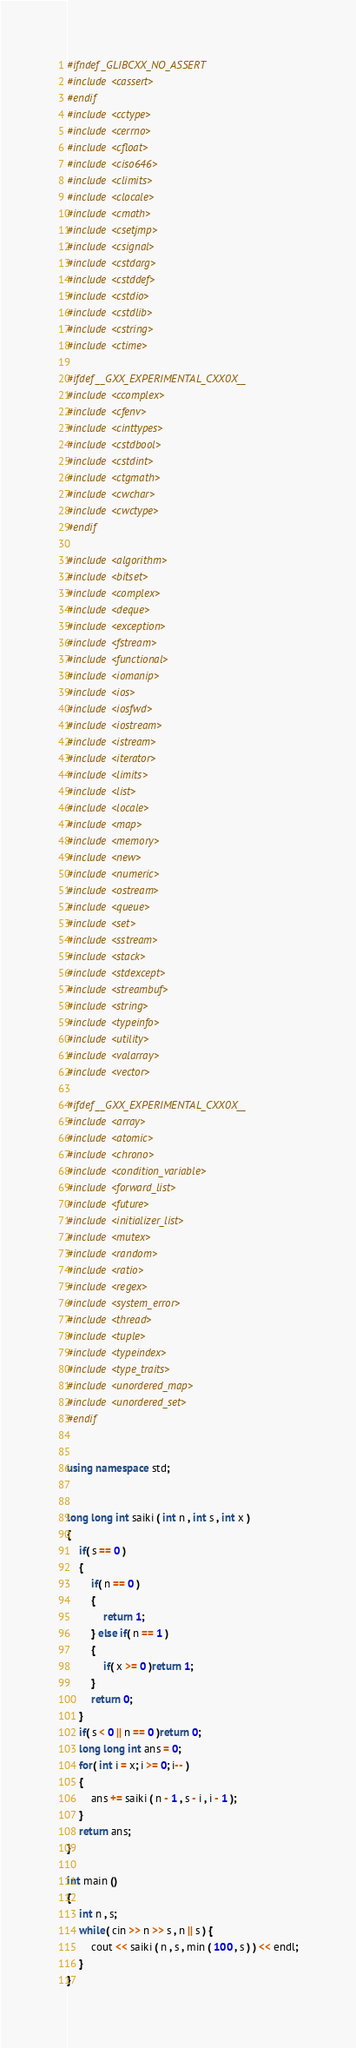Convert code to text. <code><loc_0><loc_0><loc_500><loc_500><_C++_>#ifndef _GLIBCXX_NO_ASSERT
#include <cassert>
#endif
#include <cctype>
#include <cerrno>
#include <cfloat>
#include <ciso646>
#include <climits>
#include <clocale>
#include <cmath>
#include <csetjmp>
#include <csignal>
#include <cstdarg>
#include <cstddef>
#include <cstdio>
#include <cstdlib>
#include <cstring>
#include <ctime>

#ifdef __GXX_EXPERIMENTAL_CXX0X__
#include <ccomplex>
#include <cfenv>
#include <cinttypes>
#include <cstdbool>
#include <cstdint>
#include <ctgmath>
#include <cwchar>
#include <cwctype>
#endif

#include <algorithm>
#include <bitset>
#include <complex>
#include <deque>
#include <exception>
#include <fstream>
#include <functional>
#include <iomanip>
#include <ios>
#include <iosfwd>
#include <iostream>
#include <istream>
#include <iterator>
#include <limits>
#include <list>
#include <locale>
#include <map>
#include <memory>
#include <new>
#include <numeric>
#include <ostream>
#include <queue>
#include <set>
#include <sstream>
#include <stack>
#include <stdexcept>
#include <streambuf>
#include <string>
#include <typeinfo>
#include <utility>
#include <valarray>
#include <vector>

#ifdef __GXX_EXPERIMENTAL_CXX0X__
#include <array>
#include <atomic>
#include <chrono>
#include <condition_variable>
#include <forward_list>
#include <future>
#include <initializer_list>
#include <mutex>
#include <random>
#include <ratio>
#include <regex>
#include <system_error>
#include <thread>
#include <tuple>
#include <typeindex>
#include <type_traits>
#include <unordered_map>
#include <unordered_set>
#endif


using namespace std;


long long int saiki ( int n , int s , int x )
{
	if( s == 0 )
	{
		if( n == 0 )
		{
			return 1;
		} else if( n == 1 )
		{
			if( x >= 0 )return 1;
		}
		return 0;
	}
	if( s < 0 || n == 0 )return 0;
	long long int ans = 0;
	for( int i = x; i >= 0; i-- )
	{
		ans += saiki ( n - 1 , s - i , i - 1 );
	}
	return ans;
}

int main ()
{
	int n , s;
	while( cin >> n >> s , n || s ) { 
		cout << saiki ( n , s , min ( 100 , s ) ) << endl;
	}
}</code> 